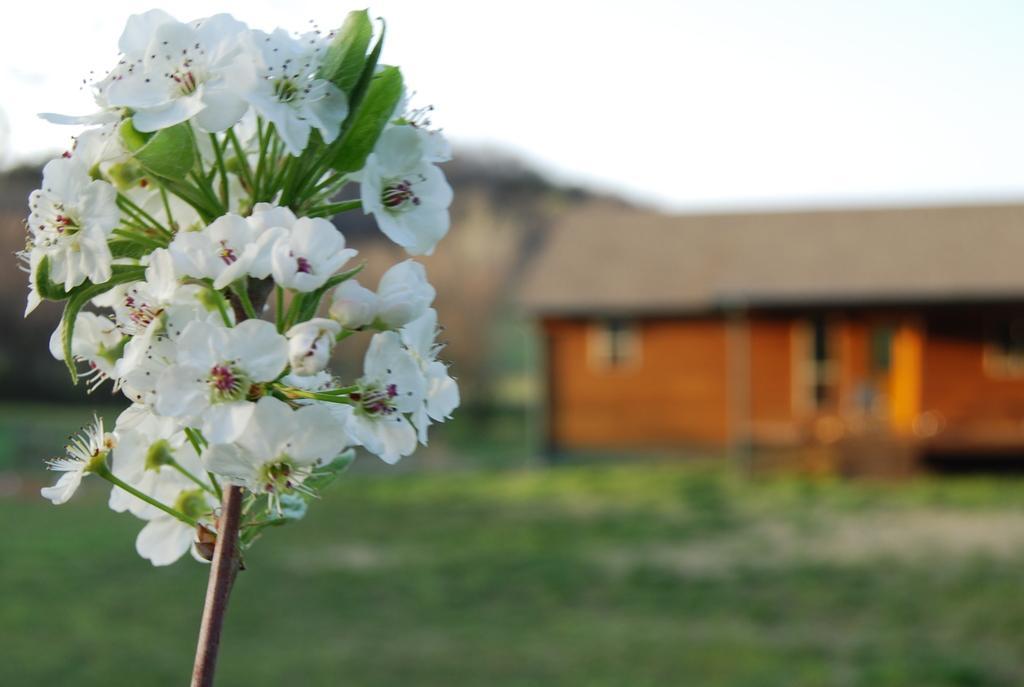Please provide a concise description of this image. In this image, we can see some flowers. There is a hut on the right side of the image. In the background, image is blurred. 